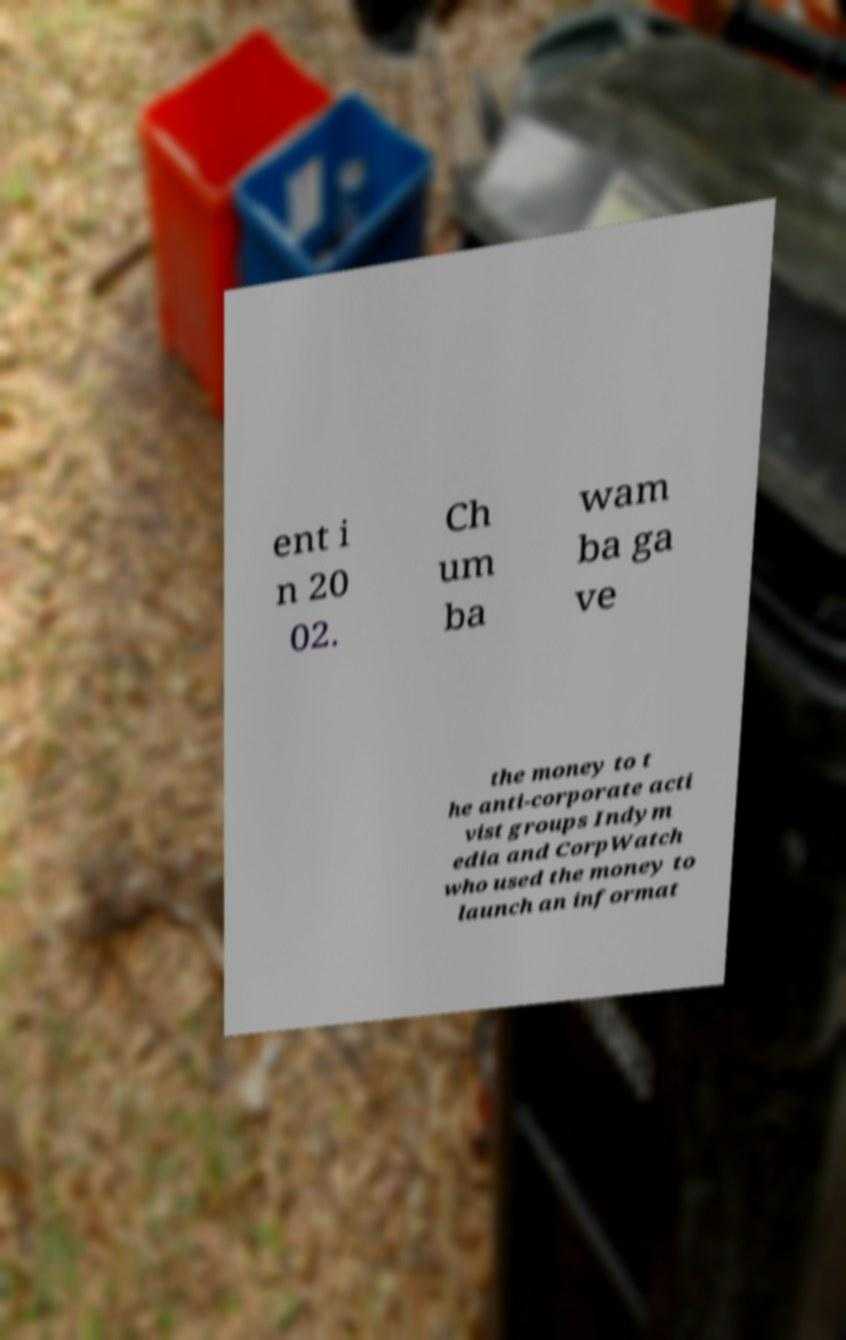What messages or text are displayed in this image? I need them in a readable, typed format. ent i n 20 02. Ch um ba wam ba ga ve the money to t he anti-corporate acti vist groups Indym edia and CorpWatch who used the money to launch an informat 